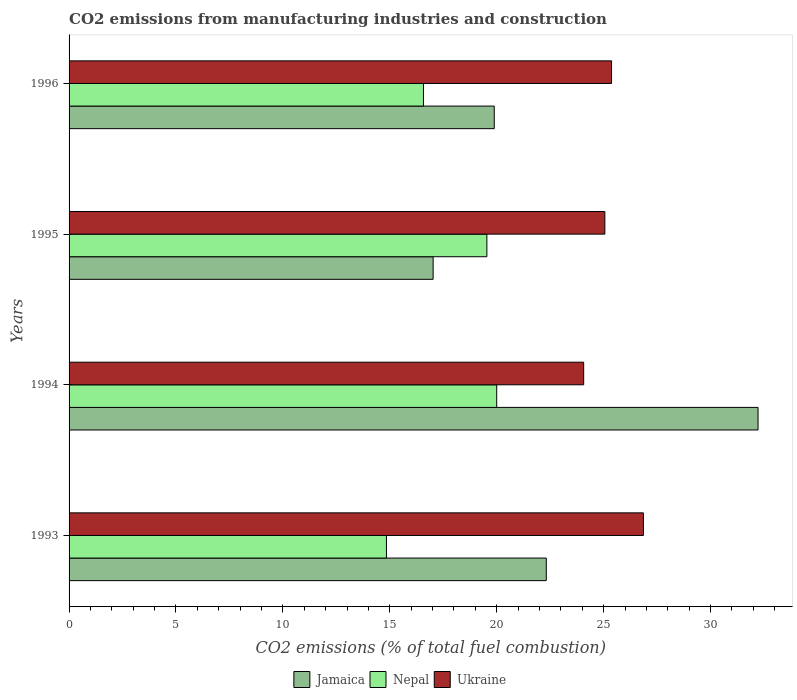How many different coloured bars are there?
Ensure brevity in your answer.  3. Are the number of bars per tick equal to the number of legend labels?
Provide a succinct answer. Yes. Are the number of bars on each tick of the Y-axis equal?
Your response must be concise. Yes. How many bars are there on the 3rd tick from the top?
Ensure brevity in your answer.  3. What is the label of the 4th group of bars from the top?
Offer a very short reply. 1993. In how many cases, is the number of bars for a given year not equal to the number of legend labels?
Offer a terse response. 0. What is the amount of CO2 emitted in Nepal in 1993?
Offer a terse response. 14.84. Across all years, what is the maximum amount of CO2 emitted in Jamaica?
Your answer should be compact. 32.22. Across all years, what is the minimum amount of CO2 emitted in Nepal?
Your answer should be compact. 14.84. What is the total amount of CO2 emitted in Nepal in the graph?
Offer a very short reply. 70.96. What is the difference between the amount of CO2 emitted in Nepal in 1994 and that in 1996?
Offer a terse response. 3.43. What is the difference between the amount of CO2 emitted in Nepal in 1994 and the amount of CO2 emitted in Ukraine in 1995?
Provide a succinct answer. -5.06. What is the average amount of CO2 emitted in Jamaica per year?
Your response must be concise. 22.86. In the year 1996, what is the difference between the amount of CO2 emitted in Nepal and amount of CO2 emitted in Ukraine?
Offer a terse response. -8.8. In how many years, is the amount of CO2 emitted in Ukraine greater than 4 %?
Your answer should be very brief. 4. What is the ratio of the amount of CO2 emitted in Ukraine in 1993 to that in 1996?
Give a very brief answer. 1.06. Is the amount of CO2 emitted in Nepal in 1993 less than that in 1994?
Provide a short and direct response. Yes. What is the difference between the highest and the second highest amount of CO2 emitted in Ukraine?
Provide a succinct answer. 1.49. What is the difference between the highest and the lowest amount of CO2 emitted in Jamaica?
Offer a terse response. 15.2. Is the sum of the amount of CO2 emitted in Ukraine in 1993 and 1994 greater than the maximum amount of CO2 emitted in Jamaica across all years?
Make the answer very short. Yes. What does the 1st bar from the top in 1993 represents?
Your answer should be compact. Ukraine. What does the 2nd bar from the bottom in 1994 represents?
Your response must be concise. Nepal. Are all the bars in the graph horizontal?
Make the answer very short. Yes. How many years are there in the graph?
Your answer should be compact. 4. What is the difference between two consecutive major ticks on the X-axis?
Ensure brevity in your answer.  5. Are the values on the major ticks of X-axis written in scientific E-notation?
Keep it short and to the point. No. Does the graph contain grids?
Keep it short and to the point. No. Where does the legend appear in the graph?
Offer a terse response. Bottom center. How many legend labels are there?
Make the answer very short. 3. What is the title of the graph?
Provide a short and direct response. CO2 emissions from manufacturing industries and construction. Does "Mozambique" appear as one of the legend labels in the graph?
Your response must be concise. No. What is the label or title of the X-axis?
Offer a very short reply. CO2 emissions (% of total fuel combustion). What is the CO2 emissions (% of total fuel combustion) of Jamaica in 1993?
Give a very brief answer. 22.32. What is the CO2 emissions (% of total fuel combustion) in Nepal in 1993?
Ensure brevity in your answer.  14.84. What is the CO2 emissions (% of total fuel combustion) of Ukraine in 1993?
Your response must be concise. 26.86. What is the CO2 emissions (% of total fuel combustion) in Jamaica in 1994?
Keep it short and to the point. 32.22. What is the CO2 emissions (% of total fuel combustion) of Nepal in 1994?
Make the answer very short. 20. What is the CO2 emissions (% of total fuel combustion) in Ukraine in 1994?
Offer a terse response. 24.07. What is the CO2 emissions (% of total fuel combustion) of Jamaica in 1995?
Offer a terse response. 17.03. What is the CO2 emissions (% of total fuel combustion) of Nepal in 1995?
Make the answer very short. 19.54. What is the CO2 emissions (% of total fuel combustion) in Ukraine in 1995?
Make the answer very short. 25.06. What is the CO2 emissions (% of total fuel combustion) of Jamaica in 1996?
Offer a terse response. 19.89. What is the CO2 emissions (% of total fuel combustion) of Nepal in 1996?
Provide a short and direct response. 16.57. What is the CO2 emissions (% of total fuel combustion) of Ukraine in 1996?
Offer a very short reply. 25.37. Across all years, what is the maximum CO2 emissions (% of total fuel combustion) of Jamaica?
Your response must be concise. 32.22. Across all years, what is the maximum CO2 emissions (% of total fuel combustion) of Ukraine?
Offer a terse response. 26.86. Across all years, what is the minimum CO2 emissions (% of total fuel combustion) in Jamaica?
Ensure brevity in your answer.  17.03. Across all years, what is the minimum CO2 emissions (% of total fuel combustion) of Nepal?
Provide a short and direct response. 14.84. Across all years, what is the minimum CO2 emissions (% of total fuel combustion) in Ukraine?
Offer a terse response. 24.07. What is the total CO2 emissions (% of total fuel combustion) in Jamaica in the graph?
Your answer should be compact. 91.45. What is the total CO2 emissions (% of total fuel combustion) of Nepal in the graph?
Offer a very short reply. 70.96. What is the total CO2 emissions (% of total fuel combustion) of Ukraine in the graph?
Offer a very short reply. 101.36. What is the difference between the CO2 emissions (% of total fuel combustion) of Jamaica in 1993 and that in 1994?
Offer a terse response. -9.9. What is the difference between the CO2 emissions (% of total fuel combustion) of Nepal in 1993 and that in 1994?
Your answer should be compact. -5.16. What is the difference between the CO2 emissions (% of total fuel combustion) in Ukraine in 1993 and that in 1994?
Keep it short and to the point. 2.79. What is the difference between the CO2 emissions (% of total fuel combustion) in Jamaica in 1993 and that in 1995?
Make the answer very short. 5.29. What is the difference between the CO2 emissions (% of total fuel combustion) in Nepal in 1993 and that in 1995?
Provide a succinct answer. -4.7. What is the difference between the CO2 emissions (% of total fuel combustion) in Ukraine in 1993 and that in 1995?
Offer a terse response. 1.8. What is the difference between the CO2 emissions (% of total fuel combustion) in Jamaica in 1993 and that in 1996?
Your answer should be very brief. 2.43. What is the difference between the CO2 emissions (% of total fuel combustion) in Nepal in 1993 and that in 1996?
Keep it short and to the point. -1.73. What is the difference between the CO2 emissions (% of total fuel combustion) of Ukraine in 1993 and that in 1996?
Keep it short and to the point. 1.49. What is the difference between the CO2 emissions (% of total fuel combustion) in Jamaica in 1994 and that in 1995?
Give a very brief answer. 15.2. What is the difference between the CO2 emissions (% of total fuel combustion) of Nepal in 1994 and that in 1995?
Your response must be concise. 0.46. What is the difference between the CO2 emissions (% of total fuel combustion) in Ukraine in 1994 and that in 1995?
Give a very brief answer. -0.99. What is the difference between the CO2 emissions (% of total fuel combustion) of Jamaica in 1994 and that in 1996?
Ensure brevity in your answer.  12.34. What is the difference between the CO2 emissions (% of total fuel combustion) in Nepal in 1994 and that in 1996?
Your answer should be compact. 3.43. What is the difference between the CO2 emissions (% of total fuel combustion) in Ukraine in 1994 and that in 1996?
Give a very brief answer. -1.3. What is the difference between the CO2 emissions (% of total fuel combustion) in Jamaica in 1995 and that in 1996?
Your answer should be compact. -2.86. What is the difference between the CO2 emissions (% of total fuel combustion) in Nepal in 1995 and that in 1996?
Ensure brevity in your answer.  2.97. What is the difference between the CO2 emissions (% of total fuel combustion) in Ukraine in 1995 and that in 1996?
Your response must be concise. -0.31. What is the difference between the CO2 emissions (% of total fuel combustion) in Jamaica in 1993 and the CO2 emissions (% of total fuel combustion) in Nepal in 1994?
Ensure brevity in your answer.  2.32. What is the difference between the CO2 emissions (% of total fuel combustion) in Jamaica in 1993 and the CO2 emissions (% of total fuel combustion) in Ukraine in 1994?
Provide a short and direct response. -1.75. What is the difference between the CO2 emissions (% of total fuel combustion) of Nepal in 1993 and the CO2 emissions (% of total fuel combustion) of Ukraine in 1994?
Offer a very short reply. -9.22. What is the difference between the CO2 emissions (% of total fuel combustion) in Jamaica in 1993 and the CO2 emissions (% of total fuel combustion) in Nepal in 1995?
Provide a succinct answer. 2.78. What is the difference between the CO2 emissions (% of total fuel combustion) of Jamaica in 1993 and the CO2 emissions (% of total fuel combustion) of Ukraine in 1995?
Provide a succinct answer. -2.74. What is the difference between the CO2 emissions (% of total fuel combustion) in Nepal in 1993 and the CO2 emissions (% of total fuel combustion) in Ukraine in 1995?
Ensure brevity in your answer.  -10.21. What is the difference between the CO2 emissions (% of total fuel combustion) in Jamaica in 1993 and the CO2 emissions (% of total fuel combustion) in Nepal in 1996?
Provide a succinct answer. 5.74. What is the difference between the CO2 emissions (% of total fuel combustion) in Jamaica in 1993 and the CO2 emissions (% of total fuel combustion) in Ukraine in 1996?
Offer a very short reply. -3.05. What is the difference between the CO2 emissions (% of total fuel combustion) of Nepal in 1993 and the CO2 emissions (% of total fuel combustion) of Ukraine in 1996?
Offer a very short reply. -10.53. What is the difference between the CO2 emissions (% of total fuel combustion) in Jamaica in 1994 and the CO2 emissions (% of total fuel combustion) in Nepal in 1995?
Provide a succinct answer. 12.68. What is the difference between the CO2 emissions (% of total fuel combustion) in Jamaica in 1994 and the CO2 emissions (% of total fuel combustion) in Ukraine in 1995?
Offer a very short reply. 7.16. What is the difference between the CO2 emissions (% of total fuel combustion) in Nepal in 1994 and the CO2 emissions (% of total fuel combustion) in Ukraine in 1995?
Your response must be concise. -5.06. What is the difference between the CO2 emissions (% of total fuel combustion) in Jamaica in 1994 and the CO2 emissions (% of total fuel combustion) in Nepal in 1996?
Offer a terse response. 15.65. What is the difference between the CO2 emissions (% of total fuel combustion) in Jamaica in 1994 and the CO2 emissions (% of total fuel combustion) in Ukraine in 1996?
Ensure brevity in your answer.  6.85. What is the difference between the CO2 emissions (% of total fuel combustion) of Nepal in 1994 and the CO2 emissions (% of total fuel combustion) of Ukraine in 1996?
Keep it short and to the point. -5.37. What is the difference between the CO2 emissions (% of total fuel combustion) of Jamaica in 1995 and the CO2 emissions (% of total fuel combustion) of Nepal in 1996?
Your answer should be compact. 0.45. What is the difference between the CO2 emissions (% of total fuel combustion) in Jamaica in 1995 and the CO2 emissions (% of total fuel combustion) in Ukraine in 1996?
Ensure brevity in your answer.  -8.34. What is the difference between the CO2 emissions (% of total fuel combustion) of Nepal in 1995 and the CO2 emissions (% of total fuel combustion) of Ukraine in 1996?
Keep it short and to the point. -5.83. What is the average CO2 emissions (% of total fuel combustion) in Jamaica per year?
Give a very brief answer. 22.86. What is the average CO2 emissions (% of total fuel combustion) in Nepal per year?
Provide a short and direct response. 17.74. What is the average CO2 emissions (% of total fuel combustion) in Ukraine per year?
Provide a succinct answer. 25.34. In the year 1993, what is the difference between the CO2 emissions (% of total fuel combustion) of Jamaica and CO2 emissions (% of total fuel combustion) of Nepal?
Your answer should be compact. 7.48. In the year 1993, what is the difference between the CO2 emissions (% of total fuel combustion) in Jamaica and CO2 emissions (% of total fuel combustion) in Ukraine?
Your response must be concise. -4.54. In the year 1993, what is the difference between the CO2 emissions (% of total fuel combustion) in Nepal and CO2 emissions (% of total fuel combustion) in Ukraine?
Provide a succinct answer. -12.02. In the year 1994, what is the difference between the CO2 emissions (% of total fuel combustion) of Jamaica and CO2 emissions (% of total fuel combustion) of Nepal?
Provide a succinct answer. 12.22. In the year 1994, what is the difference between the CO2 emissions (% of total fuel combustion) of Jamaica and CO2 emissions (% of total fuel combustion) of Ukraine?
Offer a terse response. 8.16. In the year 1994, what is the difference between the CO2 emissions (% of total fuel combustion) of Nepal and CO2 emissions (% of total fuel combustion) of Ukraine?
Ensure brevity in your answer.  -4.07. In the year 1995, what is the difference between the CO2 emissions (% of total fuel combustion) in Jamaica and CO2 emissions (% of total fuel combustion) in Nepal?
Keep it short and to the point. -2.51. In the year 1995, what is the difference between the CO2 emissions (% of total fuel combustion) of Jamaica and CO2 emissions (% of total fuel combustion) of Ukraine?
Your response must be concise. -8.03. In the year 1995, what is the difference between the CO2 emissions (% of total fuel combustion) in Nepal and CO2 emissions (% of total fuel combustion) in Ukraine?
Make the answer very short. -5.52. In the year 1996, what is the difference between the CO2 emissions (% of total fuel combustion) in Jamaica and CO2 emissions (% of total fuel combustion) in Nepal?
Offer a terse response. 3.31. In the year 1996, what is the difference between the CO2 emissions (% of total fuel combustion) in Jamaica and CO2 emissions (% of total fuel combustion) in Ukraine?
Provide a succinct answer. -5.49. In the year 1996, what is the difference between the CO2 emissions (% of total fuel combustion) in Nepal and CO2 emissions (% of total fuel combustion) in Ukraine?
Provide a short and direct response. -8.8. What is the ratio of the CO2 emissions (% of total fuel combustion) in Jamaica in 1993 to that in 1994?
Your answer should be very brief. 0.69. What is the ratio of the CO2 emissions (% of total fuel combustion) in Nepal in 1993 to that in 1994?
Offer a very short reply. 0.74. What is the ratio of the CO2 emissions (% of total fuel combustion) in Ukraine in 1993 to that in 1994?
Keep it short and to the point. 1.12. What is the ratio of the CO2 emissions (% of total fuel combustion) of Jamaica in 1993 to that in 1995?
Keep it short and to the point. 1.31. What is the ratio of the CO2 emissions (% of total fuel combustion) in Nepal in 1993 to that in 1995?
Offer a very short reply. 0.76. What is the ratio of the CO2 emissions (% of total fuel combustion) of Ukraine in 1993 to that in 1995?
Provide a succinct answer. 1.07. What is the ratio of the CO2 emissions (% of total fuel combustion) of Jamaica in 1993 to that in 1996?
Offer a very short reply. 1.12. What is the ratio of the CO2 emissions (% of total fuel combustion) of Nepal in 1993 to that in 1996?
Your answer should be compact. 0.9. What is the ratio of the CO2 emissions (% of total fuel combustion) in Ukraine in 1993 to that in 1996?
Your answer should be compact. 1.06. What is the ratio of the CO2 emissions (% of total fuel combustion) in Jamaica in 1994 to that in 1995?
Make the answer very short. 1.89. What is the ratio of the CO2 emissions (% of total fuel combustion) of Nepal in 1994 to that in 1995?
Provide a succinct answer. 1.02. What is the ratio of the CO2 emissions (% of total fuel combustion) of Ukraine in 1994 to that in 1995?
Your response must be concise. 0.96. What is the ratio of the CO2 emissions (% of total fuel combustion) in Jamaica in 1994 to that in 1996?
Offer a terse response. 1.62. What is the ratio of the CO2 emissions (% of total fuel combustion) of Nepal in 1994 to that in 1996?
Your response must be concise. 1.21. What is the ratio of the CO2 emissions (% of total fuel combustion) in Ukraine in 1994 to that in 1996?
Ensure brevity in your answer.  0.95. What is the ratio of the CO2 emissions (% of total fuel combustion) in Jamaica in 1995 to that in 1996?
Your response must be concise. 0.86. What is the ratio of the CO2 emissions (% of total fuel combustion) in Nepal in 1995 to that in 1996?
Your answer should be very brief. 1.18. What is the difference between the highest and the second highest CO2 emissions (% of total fuel combustion) in Jamaica?
Offer a terse response. 9.9. What is the difference between the highest and the second highest CO2 emissions (% of total fuel combustion) in Nepal?
Ensure brevity in your answer.  0.46. What is the difference between the highest and the second highest CO2 emissions (% of total fuel combustion) in Ukraine?
Provide a short and direct response. 1.49. What is the difference between the highest and the lowest CO2 emissions (% of total fuel combustion) of Jamaica?
Provide a succinct answer. 15.2. What is the difference between the highest and the lowest CO2 emissions (% of total fuel combustion) in Nepal?
Keep it short and to the point. 5.16. What is the difference between the highest and the lowest CO2 emissions (% of total fuel combustion) in Ukraine?
Offer a very short reply. 2.79. 